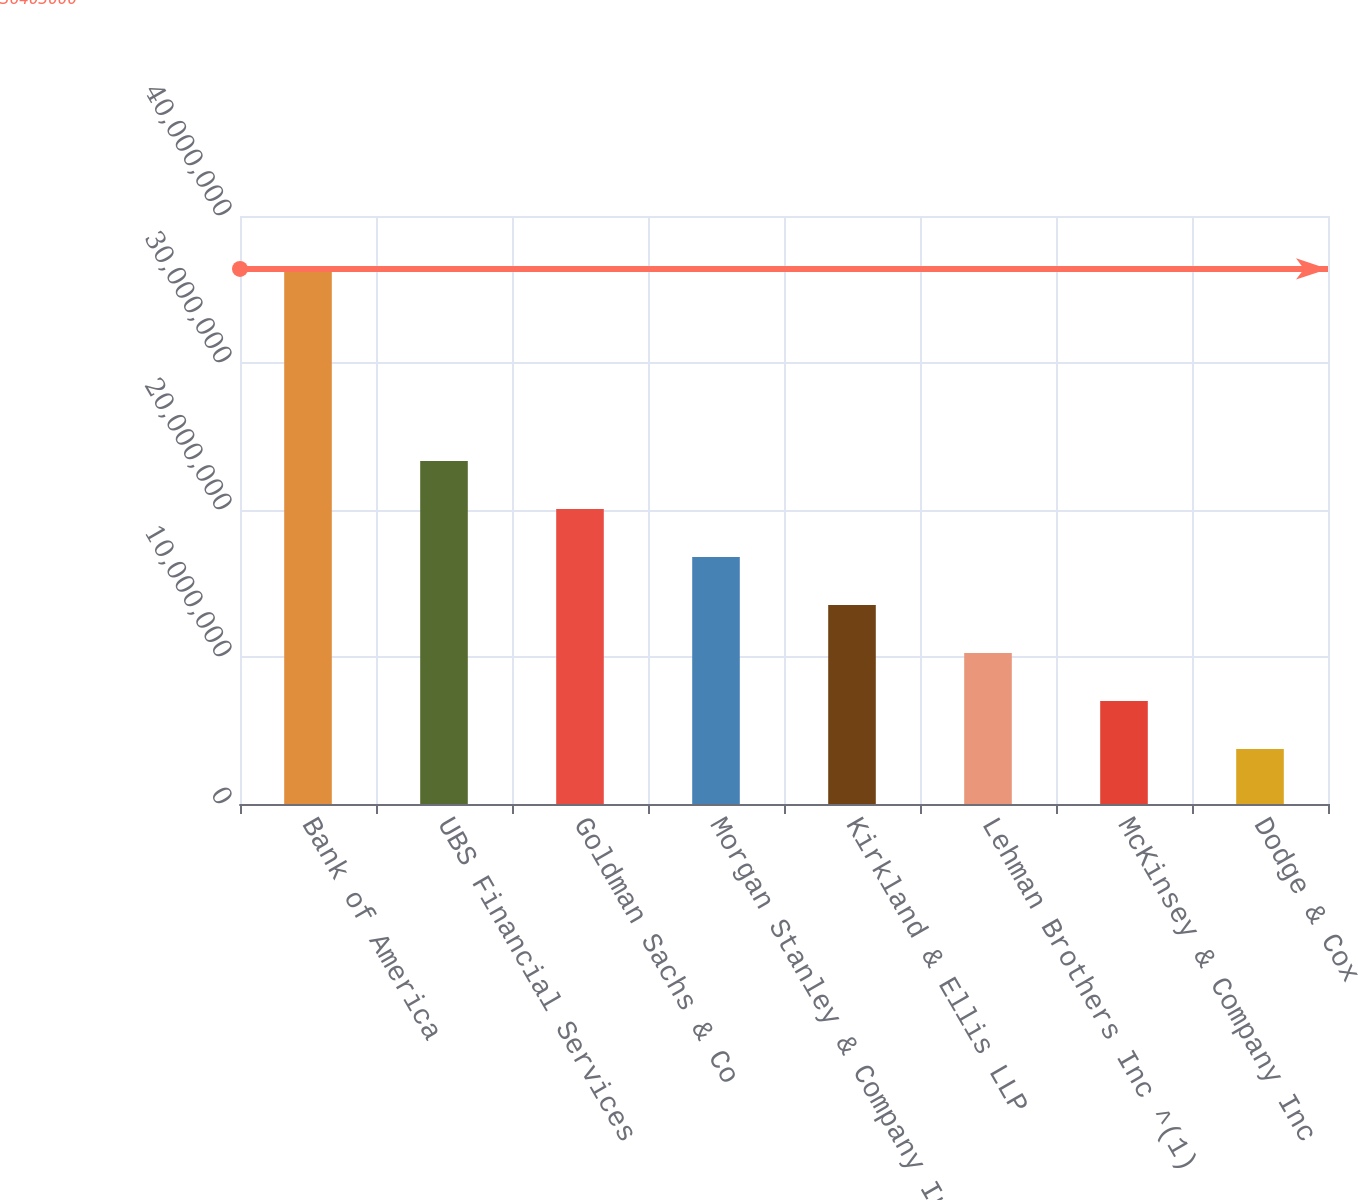Convert chart. <chart><loc_0><loc_0><loc_500><loc_500><bar_chart><fcel>Bank of America<fcel>UBS Financial Services<fcel>Goldman Sachs & Co<fcel>Morgan Stanley & Company Inc<fcel>Kirkland & Ellis LLP<fcel>Lehman Brothers Inc ^(1)<fcel>McKinsey & Company Inc<fcel>Dodge & Cox<nl><fcel>3.6403e+07<fcel>2.33362e+07<fcel>2.00695e+07<fcel>1.68028e+07<fcel>1.35361e+07<fcel>1.02694e+07<fcel>7.0027e+06<fcel>3.736e+06<nl></chart> 